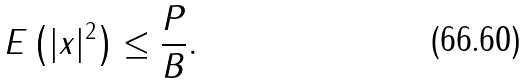Convert formula to latex. <formula><loc_0><loc_0><loc_500><loc_500>E \left ( | x | ^ { 2 } \right ) \leq \frac { P } { B } .</formula> 